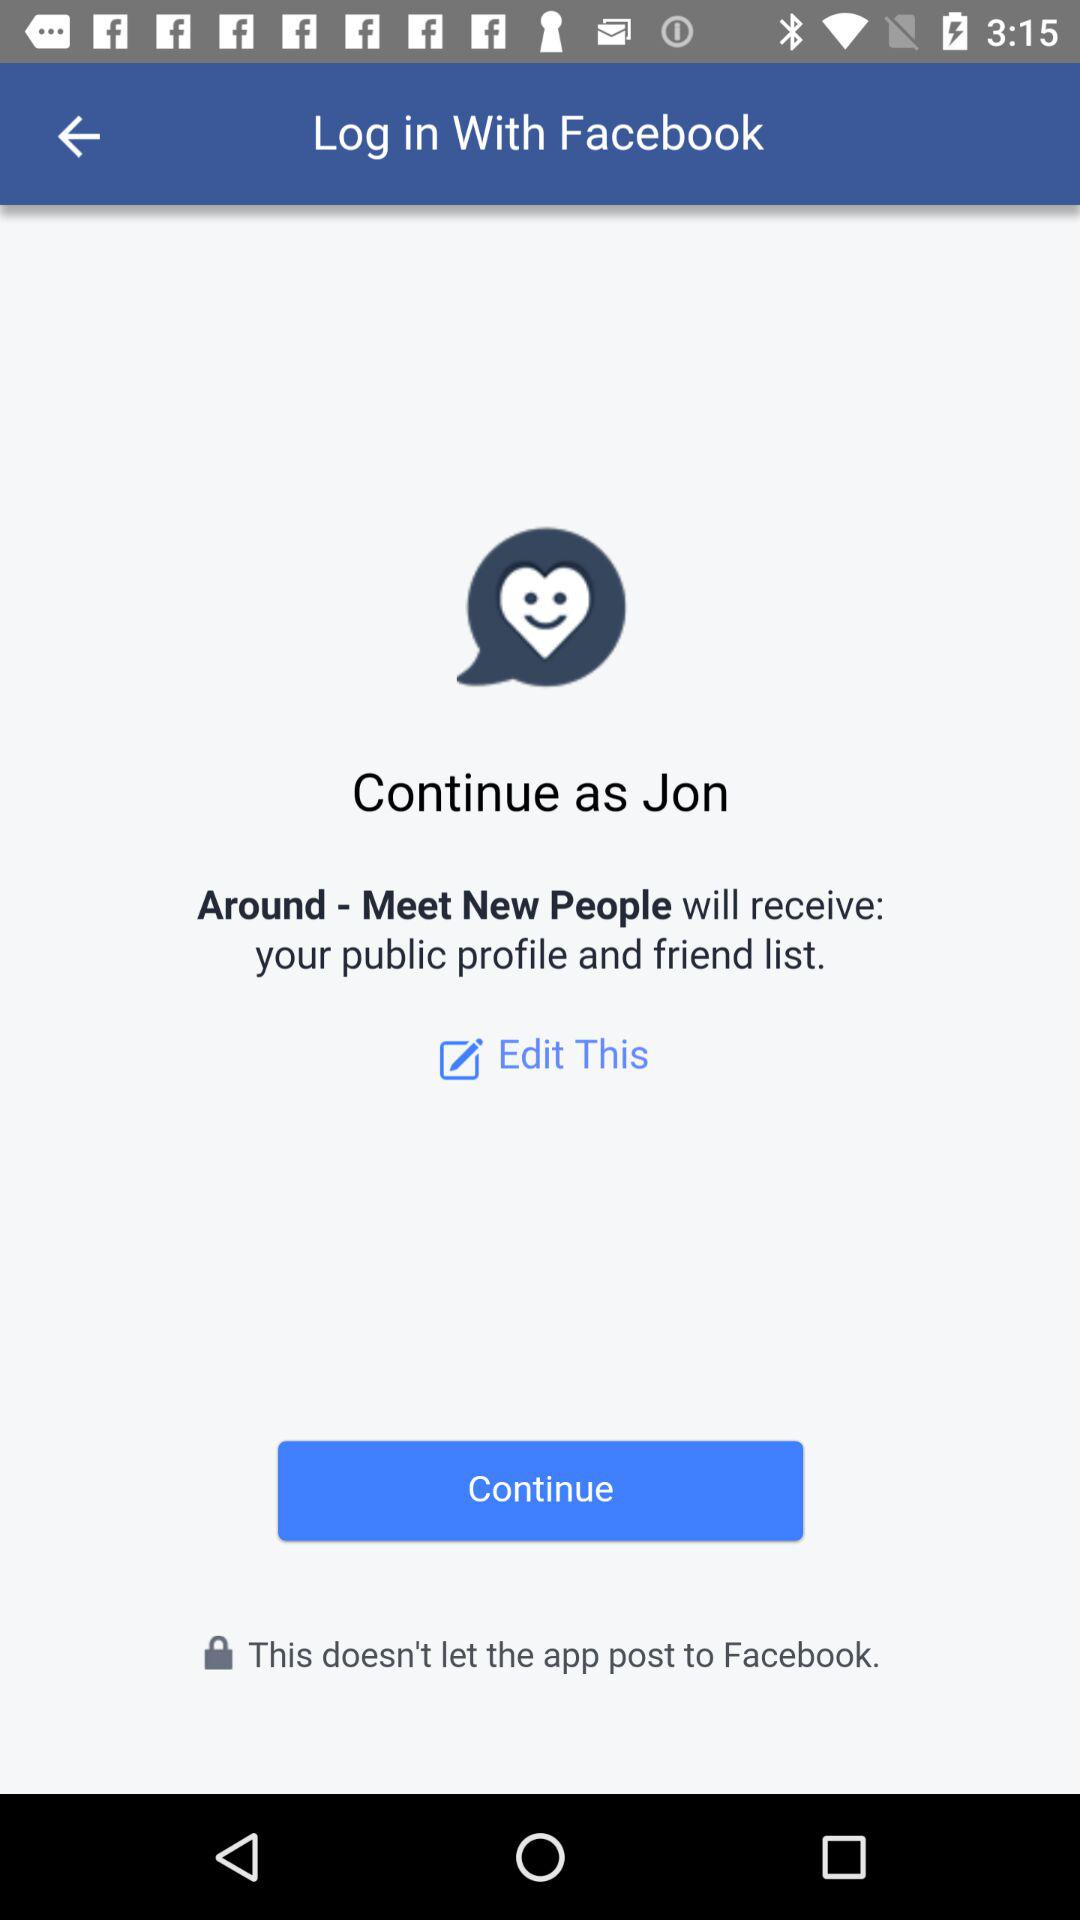What is the name of the user? The name of the user is Jon. 